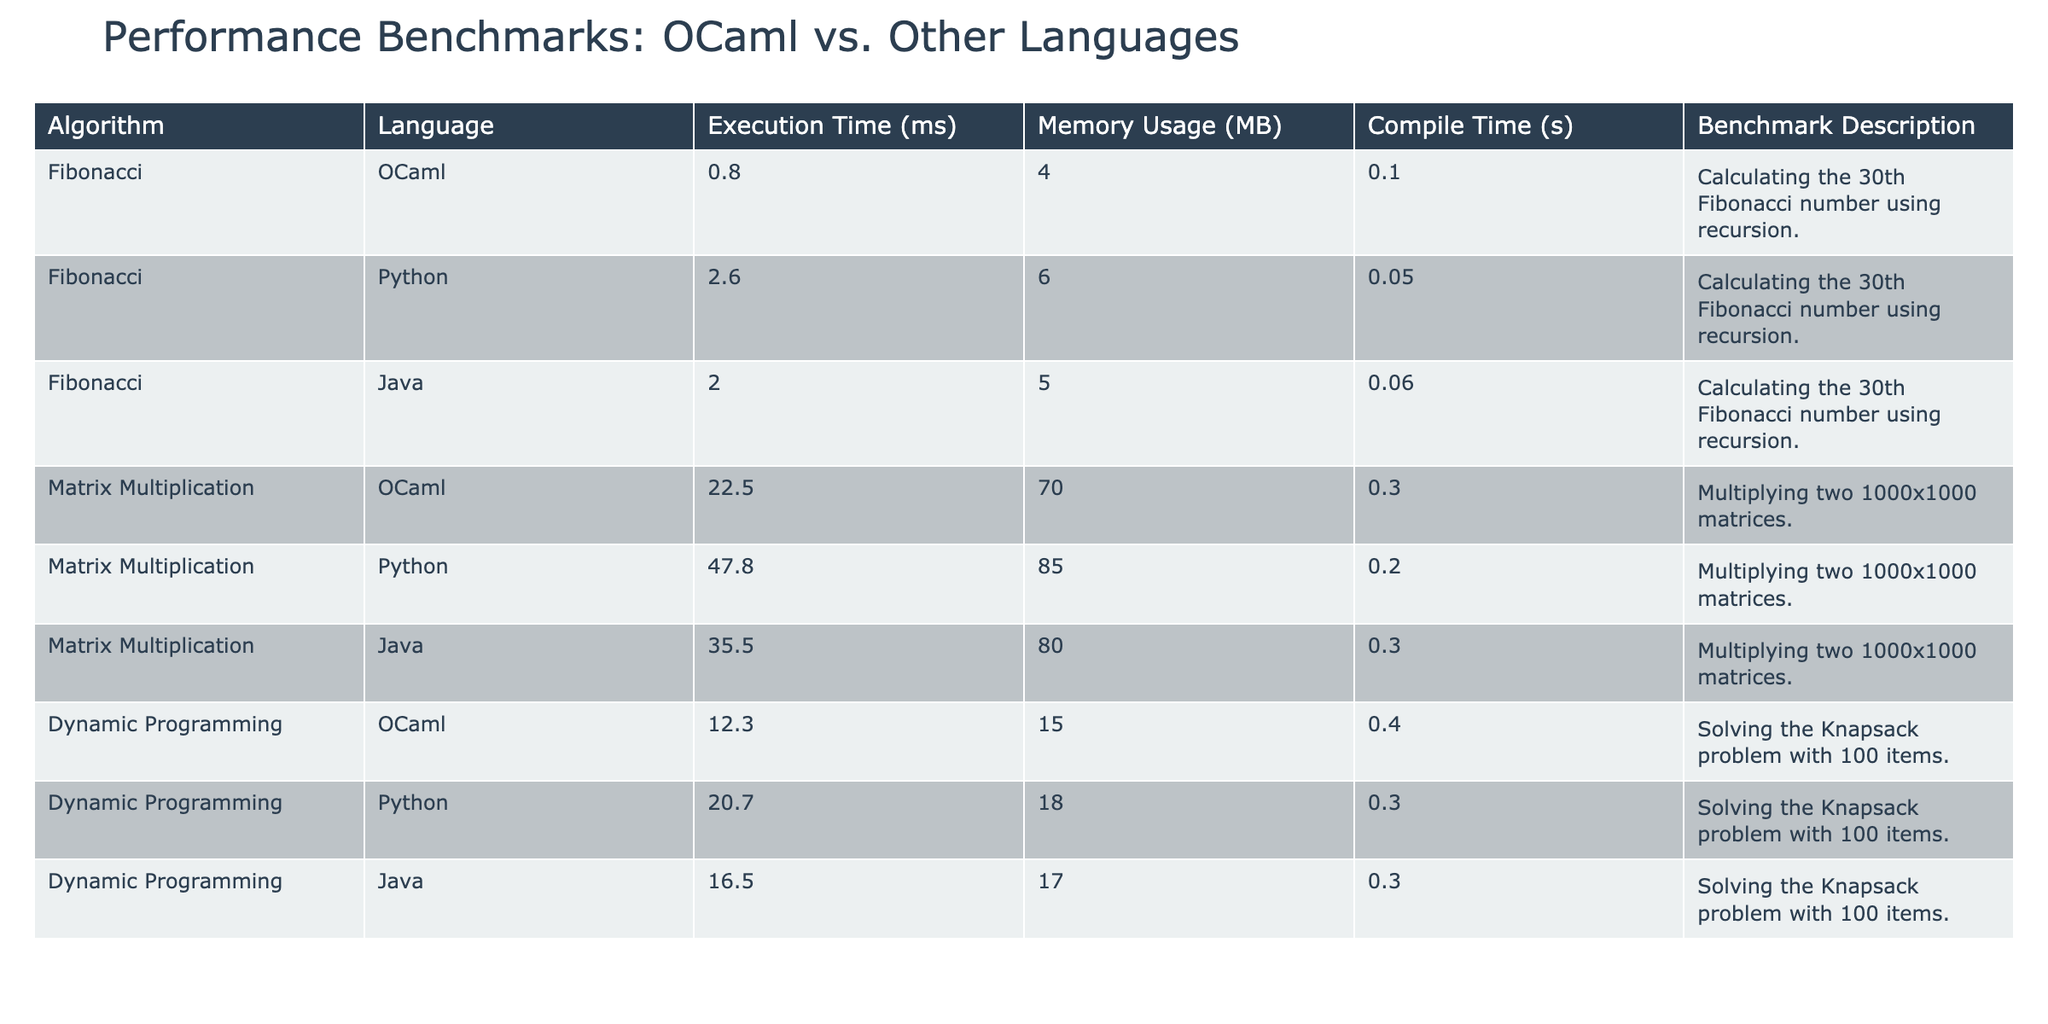What is the execution time for the Fibonacci algorithm in OCaml? The table states that the execution time for the Fibonacci algorithm implemented in OCaml is 0.8 ms.
Answer: 0.8 ms Which language has the lowest memory usage for the Matrix Multiplication algorithm? In the table, OCaml uses 70 MB, Python uses 85 MB, and Java uses 80 MB for the Matrix Multiplication algorithm; therefore, OCaml has the lowest memory usage.
Answer: OCaml What is the compile time in seconds for the Dynamic Programming algorithm implemented in Python? The table provides the compile time for Dynamic Programming in Python as 0.3 seconds.
Answer: 0.3 seconds What is the total execution time for the Fibonacci algorithm in Python and Java combined? The execution time for Python is 2.6 ms, and for Java, it is 2.0 ms. Adding these together gives 2.6 + 2.0 = 4.6 ms.
Answer: 4.6 ms Which algorithm in OCaml has the highest execution time? Comparing the execution times listed, Matrix Multiplication at 22.5 ms is higher than Fibonacci at 0.8 ms and Dynamic Programming at 12.3 ms; hence, it has the highest execution time.
Answer: Matrix Multiplication What is the average memory usage across all algorithms for OCaml? The memory usage for OCaml is 4 MB for Fibonacci, 70 MB for Matrix Multiplication, and 15 MB for Dynamic Programming. The average is (4 + 70 + 15) / 3 = 29.67 MB.
Answer: 29.67 MB Can we say that the compile time for the Fibonacci algorithm in OCaml is shorter than that of Python? The compile time for Fibonacci in OCaml is 0.1 seconds, whereas for Python, it is 0.05 seconds. Therefore, yes, OCaml's compile time is longer than Python's.
Answer: No Which programming language performed the Dynamic Programming algorithm the fastest? Looking at the execution times, OCaml at 12.3 ms is the fastest compared to Python at 20.7 ms and Java at 16.5 ms.
Answer: OCaml What is the difference in memory usage between the Matrix Multiplication algorithm in Python and Java? Python uses 85 MB while Java uses 80 MB. The difference is 85 - 80 = 5 MB.
Answer: 5 MB Which algorithm has the longest compile time across all languages? Analyzing the table, Dynamic Programming in OCaml has the longest compile time at 0.4 seconds, compared to all others.
Answer: Dynamic Programming in OCaml 